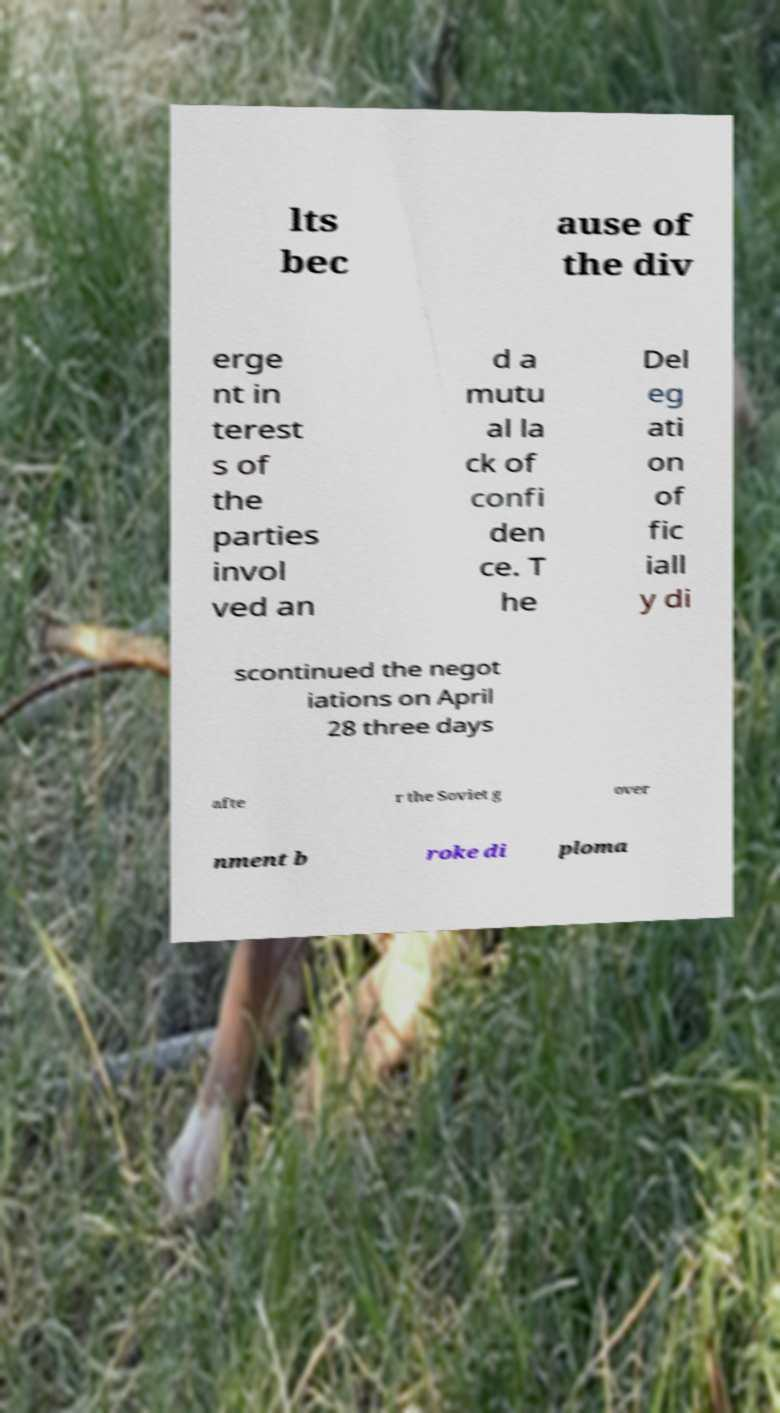Can you read and provide the text displayed in the image?This photo seems to have some interesting text. Can you extract and type it out for me? lts bec ause of the div erge nt in terest s of the parties invol ved an d a mutu al la ck of confi den ce. T he Del eg ati on of fic iall y di scontinued the negot iations on April 28 three days afte r the Soviet g over nment b roke di ploma 